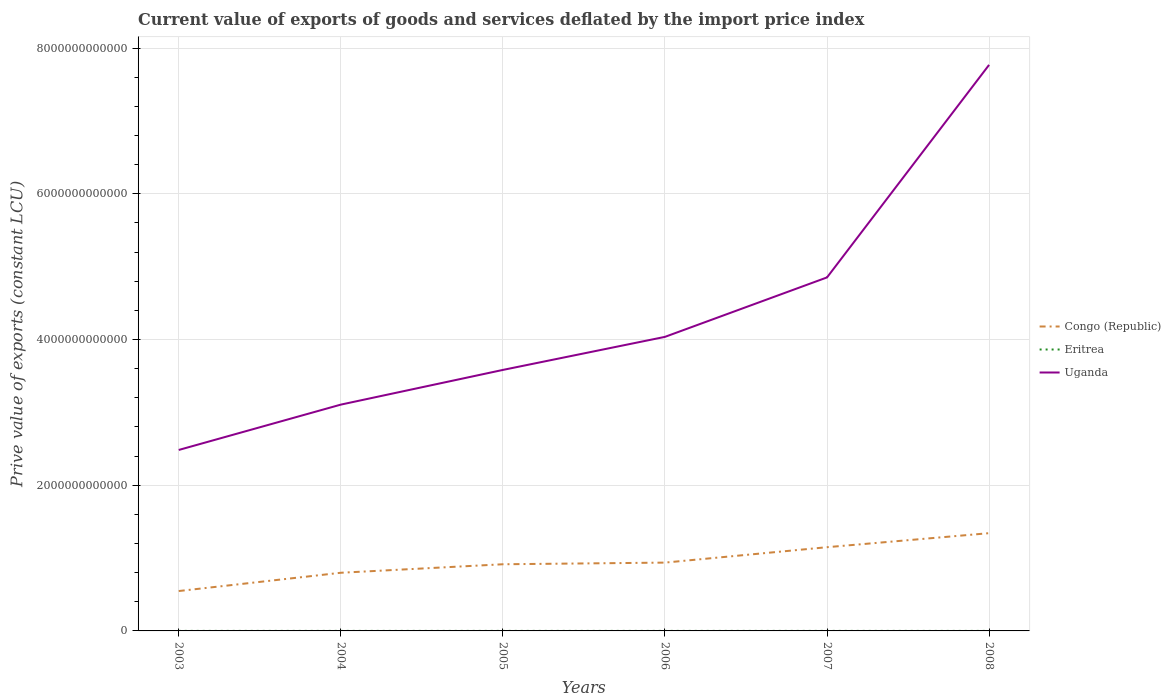How many different coloured lines are there?
Keep it short and to the point. 3. Across all years, what is the maximum prive value of exports in Uganda?
Give a very brief answer. 2.48e+12. In which year was the prive value of exports in Eritrea maximum?
Make the answer very short. 2008. What is the total prive value of exports in Uganda in the graph?
Keep it short and to the point. -2.92e+12. What is the difference between the highest and the second highest prive value of exports in Uganda?
Provide a short and direct response. 5.28e+12. Is the prive value of exports in Congo (Republic) strictly greater than the prive value of exports in Uganda over the years?
Your answer should be compact. Yes. How many years are there in the graph?
Offer a terse response. 6. What is the difference between two consecutive major ticks on the Y-axis?
Ensure brevity in your answer.  2.00e+12. Does the graph contain any zero values?
Your response must be concise. No. How many legend labels are there?
Your response must be concise. 3. How are the legend labels stacked?
Your answer should be very brief. Vertical. What is the title of the graph?
Give a very brief answer. Current value of exports of goods and services deflated by the import price index. Does "San Marino" appear as one of the legend labels in the graph?
Offer a terse response. No. What is the label or title of the X-axis?
Offer a very short reply. Years. What is the label or title of the Y-axis?
Provide a short and direct response. Prive value of exports (constant LCU). What is the Prive value of exports (constant LCU) in Congo (Republic) in 2003?
Give a very brief answer. 5.47e+11. What is the Prive value of exports (constant LCU) of Eritrea in 2003?
Provide a succinct answer. 5.18e+08. What is the Prive value of exports (constant LCU) of Uganda in 2003?
Your response must be concise. 2.48e+12. What is the Prive value of exports (constant LCU) in Congo (Republic) in 2004?
Keep it short and to the point. 7.98e+11. What is the Prive value of exports (constant LCU) of Eritrea in 2004?
Your answer should be very brief. 5.17e+08. What is the Prive value of exports (constant LCU) of Uganda in 2004?
Your answer should be compact. 3.11e+12. What is the Prive value of exports (constant LCU) of Congo (Republic) in 2005?
Offer a very short reply. 9.15e+11. What is the Prive value of exports (constant LCU) of Eritrea in 2005?
Keep it short and to the point. 4.69e+08. What is the Prive value of exports (constant LCU) of Uganda in 2005?
Your response must be concise. 3.58e+12. What is the Prive value of exports (constant LCU) in Congo (Republic) in 2006?
Make the answer very short. 9.38e+11. What is the Prive value of exports (constant LCU) in Eritrea in 2006?
Make the answer very short. 4.60e+08. What is the Prive value of exports (constant LCU) of Uganda in 2006?
Your answer should be very brief. 4.04e+12. What is the Prive value of exports (constant LCU) of Congo (Republic) in 2007?
Offer a terse response. 1.15e+12. What is the Prive value of exports (constant LCU) in Eritrea in 2007?
Ensure brevity in your answer.  3.60e+08. What is the Prive value of exports (constant LCU) in Uganda in 2007?
Ensure brevity in your answer.  4.85e+12. What is the Prive value of exports (constant LCU) of Congo (Republic) in 2008?
Your response must be concise. 1.34e+12. What is the Prive value of exports (constant LCU) of Eritrea in 2008?
Keep it short and to the point. 2.74e+08. What is the Prive value of exports (constant LCU) of Uganda in 2008?
Provide a short and direct response. 7.77e+12. Across all years, what is the maximum Prive value of exports (constant LCU) in Congo (Republic)?
Offer a very short reply. 1.34e+12. Across all years, what is the maximum Prive value of exports (constant LCU) of Eritrea?
Your response must be concise. 5.18e+08. Across all years, what is the maximum Prive value of exports (constant LCU) in Uganda?
Provide a short and direct response. 7.77e+12. Across all years, what is the minimum Prive value of exports (constant LCU) of Congo (Republic)?
Ensure brevity in your answer.  5.47e+11. Across all years, what is the minimum Prive value of exports (constant LCU) in Eritrea?
Your answer should be very brief. 2.74e+08. Across all years, what is the minimum Prive value of exports (constant LCU) in Uganda?
Keep it short and to the point. 2.48e+12. What is the total Prive value of exports (constant LCU) of Congo (Republic) in the graph?
Keep it short and to the point. 5.69e+12. What is the total Prive value of exports (constant LCU) in Eritrea in the graph?
Your answer should be compact. 2.60e+09. What is the total Prive value of exports (constant LCU) in Uganda in the graph?
Keep it short and to the point. 2.58e+13. What is the difference between the Prive value of exports (constant LCU) of Congo (Republic) in 2003 and that in 2004?
Your answer should be very brief. -2.51e+11. What is the difference between the Prive value of exports (constant LCU) in Eritrea in 2003 and that in 2004?
Offer a very short reply. 6.15e+05. What is the difference between the Prive value of exports (constant LCU) in Uganda in 2003 and that in 2004?
Ensure brevity in your answer.  -6.22e+11. What is the difference between the Prive value of exports (constant LCU) of Congo (Republic) in 2003 and that in 2005?
Provide a short and direct response. -3.68e+11. What is the difference between the Prive value of exports (constant LCU) of Eritrea in 2003 and that in 2005?
Your response must be concise. 4.90e+07. What is the difference between the Prive value of exports (constant LCU) in Uganda in 2003 and that in 2005?
Your answer should be compact. -1.10e+12. What is the difference between the Prive value of exports (constant LCU) of Congo (Republic) in 2003 and that in 2006?
Give a very brief answer. -3.90e+11. What is the difference between the Prive value of exports (constant LCU) in Eritrea in 2003 and that in 2006?
Offer a terse response. 5.82e+07. What is the difference between the Prive value of exports (constant LCU) in Uganda in 2003 and that in 2006?
Your response must be concise. -1.55e+12. What is the difference between the Prive value of exports (constant LCU) of Congo (Republic) in 2003 and that in 2007?
Keep it short and to the point. -6.02e+11. What is the difference between the Prive value of exports (constant LCU) in Eritrea in 2003 and that in 2007?
Your answer should be very brief. 1.58e+08. What is the difference between the Prive value of exports (constant LCU) of Uganda in 2003 and that in 2007?
Make the answer very short. -2.37e+12. What is the difference between the Prive value of exports (constant LCU) in Congo (Republic) in 2003 and that in 2008?
Your response must be concise. -7.94e+11. What is the difference between the Prive value of exports (constant LCU) of Eritrea in 2003 and that in 2008?
Provide a short and direct response. 2.44e+08. What is the difference between the Prive value of exports (constant LCU) in Uganda in 2003 and that in 2008?
Your answer should be compact. -5.28e+12. What is the difference between the Prive value of exports (constant LCU) of Congo (Republic) in 2004 and that in 2005?
Provide a succinct answer. -1.17e+11. What is the difference between the Prive value of exports (constant LCU) of Eritrea in 2004 and that in 2005?
Keep it short and to the point. 4.84e+07. What is the difference between the Prive value of exports (constant LCU) in Uganda in 2004 and that in 2005?
Offer a very short reply. -4.76e+11. What is the difference between the Prive value of exports (constant LCU) of Congo (Republic) in 2004 and that in 2006?
Keep it short and to the point. -1.39e+11. What is the difference between the Prive value of exports (constant LCU) in Eritrea in 2004 and that in 2006?
Provide a succinct answer. 5.76e+07. What is the difference between the Prive value of exports (constant LCU) of Uganda in 2004 and that in 2006?
Provide a short and direct response. -9.30e+11. What is the difference between the Prive value of exports (constant LCU) of Congo (Republic) in 2004 and that in 2007?
Make the answer very short. -3.51e+11. What is the difference between the Prive value of exports (constant LCU) in Eritrea in 2004 and that in 2007?
Your response must be concise. 1.58e+08. What is the difference between the Prive value of exports (constant LCU) in Uganda in 2004 and that in 2007?
Your answer should be compact. -1.75e+12. What is the difference between the Prive value of exports (constant LCU) in Congo (Republic) in 2004 and that in 2008?
Provide a short and direct response. -5.43e+11. What is the difference between the Prive value of exports (constant LCU) of Eritrea in 2004 and that in 2008?
Your response must be concise. 2.44e+08. What is the difference between the Prive value of exports (constant LCU) in Uganda in 2004 and that in 2008?
Ensure brevity in your answer.  -4.66e+12. What is the difference between the Prive value of exports (constant LCU) in Congo (Republic) in 2005 and that in 2006?
Ensure brevity in your answer.  -2.27e+1. What is the difference between the Prive value of exports (constant LCU) of Eritrea in 2005 and that in 2006?
Provide a succinct answer. 9.15e+06. What is the difference between the Prive value of exports (constant LCU) in Uganda in 2005 and that in 2006?
Make the answer very short. -4.54e+11. What is the difference between the Prive value of exports (constant LCU) of Congo (Republic) in 2005 and that in 2007?
Provide a succinct answer. -2.34e+11. What is the difference between the Prive value of exports (constant LCU) of Eritrea in 2005 and that in 2007?
Your answer should be very brief. 1.09e+08. What is the difference between the Prive value of exports (constant LCU) in Uganda in 2005 and that in 2007?
Make the answer very short. -1.27e+12. What is the difference between the Prive value of exports (constant LCU) of Congo (Republic) in 2005 and that in 2008?
Your answer should be very brief. -4.27e+11. What is the difference between the Prive value of exports (constant LCU) in Eritrea in 2005 and that in 2008?
Keep it short and to the point. 1.95e+08. What is the difference between the Prive value of exports (constant LCU) in Uganda in 2005 and that in 2008?
Provide a short and direct response. -4.19e+12. What is the difference between the Prive value of exports (constant LCU) of Congo (Republic) in 2006 and that in 2007?
Give a very brief answer. -2.12e+11. What is the difference between the Prive value of exports (constant LCU) in Eritrea in 2006 and that in 2007?
Offer a very short reply. 1.00e+08. What is the difference between the Prive value of exports (constant LCU) in Uganda in 2006 and that in 2007?
Provide a succinct answer. -8.16e+11. What is the difference between the Prive value of exports (constant LCU) of Congo (Republic) in 2006 and that in 2008?
Your answer should be very brief. -4.04e+11. What is the difference between the Prive value of exports (constant LCU) of Eritrea in 2006 and that in 2008?
Ensure brevity in your answer.  1.86e+08. What is the difference between the Prive value of exports (constant LCU) of Uganda in 2006 and that in 2008?
Your response must be concise. -3.73e+12. What is the difference between the Prive value of exports (constant LCU) in Congo (Republic) in 2007 and that in 2008?
Provide a short and direct response. -1.93e+11. What is the difference between the Prive value of exports (constant LCU) in Eritrea in 2007 and that in 2008?
Give a very brief answer. 8.60e+07. What is the difference between the Prive value of exports (constant LCU) in Uganda in 2007 and that in 2008?
Your answer should be compact. -2.92e+12. What is the difference between the Prive value of exports (constant LCU) of Congo (Republic) in 2003 and the Prive value of exports (constant LCU) of Eritrea in 2004?
Your answer should be compact. 5.47e+11. What is the difference between the Prive value of exports (constant LCU) in Congo (Republic) in 2003 and the Prive value of exports (constant LCU) in Uganda in 2004?
Offer a terse response. -2.56e+12. What is the difference between the Prive value of exports (constant LCU) in Eritrea in 2003 and the Prive value of exports (constant LCU) in Uganda in 2004?
Provide a short and direct response. -3.11e+12. What is the difference between the Prive value of exports (constant LCU) of Congo (Republic) in 2003 and the Prive value of exports (constant LCU) of Eritrea in 2005?
Your answer should be very brief. 5.47e+11. What is the difference between the Prive value of exports (constant LCU) of Congo (Republic) in 2003 and the Prive value of exports (constant LCU) of Uganda in 2005?
Keep it short and to the point. -3.03e+12. What is the difference between the Prive value of exports (constant LCU) of Eritrea in 2003 and the Prive value of exports (constant LCU) of Uganda in 2005?
Your response must be concise. -3.58e+12. What is the difference between the Prive value of exports (constant LCU) of Congo (Republic) in 2003 and the Prive value of exports (constant LCU) of Eritrea in 2006?
Provide a succinct answer. 5.47e+11. What is the difference between the Prive value of exports (constant LCU) in Congo (Republic) in 2003 and the Prive value of exports (constant LCU) in Uganda in 2006?
Make the answer very short. -3.49e+12. What is the difference between the Prive value of exports (constant LCU) of Eritrea in 2003 and the Prive value of exports (constant LCU) of Uganda in 2006?
Offer a very short reply. -4.04e+12. What is the difference between the Prive value of exports (constant LCU) in Congo (Republic) in 2003 and the Prive value of exports (constant LCU) in Eritrea in 2007?
Your answer should be compact. 5.47e+11. What is the difference between the Prive value of exports (constant LCU) in Congo (Republic) in 2003 and the Prive value of exports (constant LCU) in Uganda in 2007?
Offer a very short reply. -4.30e+12. What is the difference between the Prive value of exports (constant LCU) of Eritrea in 2003 and the Prive value of exports (constant LCU) of Uganda in 2007?
Keep it short and to the point. -4.85e+12. What is the difference between the Prive value of exports (constant LCU) of Congo (Republic) in 2003 and the Prive value of exports (constant LCU) of Eritrea in 2008?
Make the answer very short. 5.47e+11. What is the difference between the Prive value of exports (constant LCU) of Congo (Republic) in 2003 and the Prive value of exports (constant LCU) of Uganda in 2008?
Provide a short and direct response. -7.22e+12. What is the difference between the Prive value of exports (constant LCU) in Eritrea in 2003 and the Prive value of exports (constant LCU) in Uganda in 2008?
Ensure brevity in your answer.  -7.77e+12. What is the difference between the Prive value of exports (constant LCU) of Congo (Republic) in 2004 and the Prive value of exports (constant LCU) of Eritrea in 2005?
Offer a very short reply. 7.98e+11. What is the difference between the Prive value of exports (constant LCU) of Congo (Republic) in 2004 and the Prive value of exports (constant LCU) of Uganda in 2005?
Keep it short and to the point. -2.78e+12. What is the difference between the Prive value of exports (constant LCU) of Eritrea in 2004 and the Prive value of exports (constant LCU) of Uganda in 2005?
Provide a succinct answer. -3.58e+12. What is the difference between the Prive value of exports (constant LCU) in Congo (Republic) in 2004 and the Prive value of exports (constant LCU) in Eritrea in 2006?
Your response must be concise. 7.98e+11. What is the difference between the Prive value of exports (constant LCU) of Congo (Republic) in 2004 and the Prive value of exports (constant LCU) of Uganda in 2006?
Ensure brevity in your answer.  -3.24e+12. What is the difference between the Prive value of exports (constant LCU) in Eritrea in 2004 and the Prive value of exports (constant LCU) in Uganda in 2006?
Keep it short and to the point. -4.04e+12. What is the difference between the Prive value of exports (constant LCU) in Congo (Republic) in 2004 and the Prive value of exports (constant LCU) in Eritrea in 2007?
Your answer should be very brief. 7.98e+11. What is the difference between the Prive value of exports (constant LCU) of Congo (Republic) in 2004 and the Prive value of exports (constant LCU) of Uganda in 2007?
Make the answer very short. -4.05e+12. What is the difference between the Prive value of exports (constant LCU) of Eritrea in 2004 and the Prive value of exports (constant LCU) of Uganda in 2007?
Give a very brief answer. -4.85e+12. What is the difference between the Prive value of exports (constant LCU) of Congo (Republic) in 2004 and the Prive value of exports (constant LCU) of Eritrea in 2008?
Offer a very short reply. 7.98e+11. What is the difference between the Prive value of exports (constant LCU) of Congo (Republic) in 2004 and the Prive value of exports (constant LCU) of Uganda in 2008?
Your response must be concise. -6.97e+12. What is the difference between the Prive value of exports (constant LCU) in Eritrea in 2004 and the Prive value of exports (constant LCU) in Uganda in 2008?
Make the answer very short. -7.77e+12. What is the difference between the Prive value of exports (constant LCU) of Congo (Republic) in 2005 and the Prive value of exports (constant LCU) of Eritrea in 2006?
Give a very brief answer. 9.14e+11. What is the difference between the Prive value of exports (constant LCU) of Congo (Republic) in 2005 and the Prive value of exports (constant LCU) of Uganda in 2006?
Keep it short and to the point. -3.12e+12. What is the difference between the Prive value of exports (constant LCU) in Eritrea in 2005 and the Prive value of exports (constant LCU) in Uganda in 2006?
Your answer should be compact. -4.04e+12. What is the difference between the Prive value of exports (constant LCU) of Congo (Republic) in 2005 and the Prive value of exports (constant LCU) of Eritrea in 2007?
Provide a succinct answer. 9.15e+11. What is the difference between the Prive value of exports (constant LCU) in Congo (Republic) in 2005 and the Prive value of exports (constant LCU) in Uganda in 2007?
Make the answer very short. -3.94e+12. What is the difference between the Prive value of exports (constant LCU) in Eritrea in 2005 and the Prive value of exports (constant LCU) in Uganda in 2007?
Your answer should be very brief. -4.85e+12. What is the difference between the Prive value of exports (constant LCU) of Congo (Republic) in 2005 and the Prive value of exports (constant LCU) of Eritrea in 2008?
Your answer should be compact. 9.15e+11. What is the difference between the Prive value of exports (constant LCU) in Congo (Republic) in 2005 and the Prive value of exports (constant LCU) in Uganda in 2008?
Provide a succinct answer. -6.85e+12. What is the difference between the Prive value of exports (constant LCU) in Eritrea in 2005 and the Prive value of exports (constant LCU) in Uganda in 2008?
Your answer should be very brief. -7.77e+12. What is the difference between the Prive value of exports (constant LCU) of Congo (Republic) in 2006 and the Prive value of exports (constant LCU) of Eritrea in 2007?
Provide a short and direct response. 9.37e+11. What is the difference between the Prive value of exports (constant LCU) in Congo (Republic) in 2006 and the Prive value of exports (constant LCU) in Uganda in 2007?
Give a very brief answer. -3.91e+12. What is the difference between the Prive value of exports (constant LCU) in Eritrea in 2006 and the Prive value of exports (constant LCU) in Uganda in 2007?
Provide a short and direct response. -4.85e+12. What is the difference between the Prive value of exports (constant LCU) in Congo (Republic) in 2006 and the Prive value of exports (constant LCU) in Eritrea in 2008?
Offer a very short reply. 9.37e+11. What is the difference between the Prive value of exports (constant LCU) of Congo (Republic) in 2006 and the Prive value of exports (constant LCU) of Uganda in 2008?
Ensure brevity in your answer.  -6.83e+12. What is the difference between the Prive value of exports (constant LCU) of Eritrea in 2006 and the Prive value of exports (constant LCU) of Uganda in 2008?
Offer a terse response. -7.77e+12. What is the difference between the Prive value of exports (constant LCU) of Congo (Republic) in 2007 and the Prive value of exports (constant LCU) of Eritrea in 2008?
Your answer should be compact. 1.15e+12. What is the difference between the Prive value of exports (constant LCU) of Congo (Republic) in 2007 and the Prive value of exports (constant LCU) of Uganda in 2008?
Offer a terse response. -6.62e+12. What is the difference between the Prive value of exports (constant LCU) of Eritrea in 2007 and the Prive value of exports (constant LCU) of Uganda in 2008?
Offer a terse response. -7.77e+12. What is the average Prive value of exports (constant LCU) in Congo (Republic) per year?
Give a very brief answer. 9.48e+11. What is the average Prive value of exports (constant LCU) in Eritrea per year?
Provide a succinct answer. 4.33e+08. What is the average Prive value of exports (constant LCU) of Uganda per year?
Give a very brief answer. 4.30e+12. In the year 2003, what is the difference between the Prive value of exports (constant LCU) of Congo (Republic) and Prive value of exports (constant LCU) of Eritrea?
Your response must be concise. 5.47e+11. In the year 2003, what is the difference between the Prive value of exports (constant LCU) in Congo (Republic) and Prive value of exports (constant LCU) in Uganda?
Provide a short and direct response. -1.94e+12. In the year 2003, what is the difference between the Prive value of exports (constant LCU) of Eritrea and Prive value of exports (constant LCU) of Uganda?
Offer a very short reply. -2.48e+12. In the year 2004, what is the difference between the Prive value of exports (constant LCU) in Congo (Republic) and Prive value of exports (constant LCU) in Eritrea?
Your answer should be very brief. 7.98e+11. In the year 2004, what is the difference between the Prive value of exports (constant LCU) of Congo (Republic) and Prive value of exports (constant LCU) of Uganda?
Give a very brief answer. -2.31e+12. In the year 2004, what is the difference between the Prive value of exports (constant LCU) of Eritrea and Prive value of exports (constant LCU) of Uganda?
Your answer should be compact. -3.11e+12. In the year 2005, what is the difference between the Prive value of exports (constant LCU) of Congo (Republic) and Prive value of exports (constant LCU) of Eritrea?
Give a very brief answer. 9.14e+11. In the year 2005, what is the difference between the Prive value of exports (constant LCU) of Congo (Republic) and Prive value of exports (constant LCU) of Uganda?
Provide a succinct answer. -2.67e+12. In the year 2005, what is the difference between the Prive value of exports (constant LCU) of Eritrea and Prive value of exports (constant LCU) of Uganda?
Keep it short and to the point. -3.58e+12. In the year 2006, what is the difference between the Prive value of exports (constant LCU) in Congo (Republic) and Prive value of exports (constant LCU) in Eritrea?
Your answer should be very brief. 9.37e+11. In the year 2006, what is the difference between the Prive value of exports (constant LCU) of Congo (Republic) and Prive value of exports (constant LCU) of Uganda?
Make the answer very short. -3.10e+12. In the year 2006, what is the difference between the Prive value of exports (constant LCU) of Eritrea and Prive value of exports (constant LCU) of Uganda?
Give a very brief answer. -4.04e+12. In the year 2007, what is the difference between the Prive value of exports (constant LCU) of Congo (Republic) and Prive value of exports (constant LCU) of Eritrea?
Your answer should be compact. 1.15e+12. In the year 2007, what is the difference between the Prive value of exports (constant LCU) of Congo (Republic) and Prive value of exports (constant LCU) of Uganda?
Your response must be concise. -3.70e+12. In the year 2007, what is the difference between the Prive value of exports (constant LCU) of Eritrea and Prive value of exports (constant LCU) of Uganda?
Give a very brief answer. -4.85e+12. In the year 2008, what is the difference between the Prive value of exports (constant LCU) in Congo (Republic) and Prive value of exports (constant LCU) in Eritrea?
Give a very brief answer. 1.34e+12. In the year 2008, what is the difference between the Prive value of exports (constant LCU) of Congo (Republic) and Prive value of exports (constant LCU) of Uganda?
Make the answer very short. -6.43e+12. In the year 2008, what is the difference between the Prive value of exports (constant LCU) of Eritrea and Prive value of exports (constant LCU) of Uganda?
Offer a terse response. -7.77e+12. What is the ratio of the Prive value of exports (constant LCU) of Congo (Republic) in 2003 to that in 2004?
Ensure brevity in your answer.  0.69. What is the ratio of the Prive value of exports (constant LCU) of Uganda in 2003 to that in 2004?
Make the answer very short. 0.8. What is the ratio of the Prive value of exports (constant LCU) in Congo (Republic) in 2003 to that in 2005?
Your answer should be compact. 0.6. What is the ratio of the Prive value of exports (constant LCU) of Eritrea in 2003 to that in 2005?
Offer a terse response. 1.1. What is the ratio of the Prive value of exports (constant LCU) of Uganda in 2003 to that in 2005?
Your answer should be very brief. 0.69. What is the ratio of the Prive value of exports (constant LCU) in Congo (Republic) in 2003 to that in 2006?
Ensure brevity in your answer.  0.58. What is the ratio of the Prive value of exports (constant LCU) in Eritrea in 2003 to that in 2006?
Your answer should be compact. 1.13. What is the ratio of the Prive value of exports (constant LCU) in Uganda in 2003 to that in 2006?
Give a very brief answer. 0.62. What is the ratio of the Prive value of exports (constant LCU) of Congo (Republic) in 2003 to that in 2007?
Provide a succinct answer. 0.48. What is the ratio of the Prive value of exports (constant LCU) in Eritrea in 2003 to that in 2007?
Ensure brevity in your answer.  1.44. What is the ratio of the Prive value of exports (constant LCU) in Uganda in 2003 to that in 2007?
Provide a short and direct response. 0.51. What is the ratio of the Prive value of exports (constant LCU) in Congo (Republic) in 2003 to that in 2008?
Offer a very short reply. 0.41. What is the ratio of the Prive value of exports (constant LCU) of Eritrea in 2003 to that in 2008?
Provide a succinct answer. 1.89. What is the ratio of the Prive value of exports (constant LCU) of Uganda in 2003 to that in 2008?
Your response must be concise. 0.32. What is the ratio of the Prive value of exports (constant LCU) in Congo (Republic) in 2004 to that in 2005?
Offer a terse response. 0.87. What is the ratio of the Prive value of exports (constant LCU) of Eritrea in 2004 to that in 2005?
Provide a succinct answer. 1.1. What is the ratio of the Prive value of exports (constant LCU) in Uganda in 2004 to that in 2005?
Ensure brevity in your answer.  0.87. What is the ratio of the Prive value of exports (constant LCU) in Congo (Republic) in 2004 to that in 2006?
Your response must be concise. 0.85. What is the ratio of the Prive value of exports (constant LCU) of Eritrea in 2004 to that in 2006?
Your answer should be very brief. 1.13. What is the ratio of the Prive value of exports (constant LCU) in Uganda in 2004 to that in 2006?
Offer a terse response. 0.77. What is the ratio of the Prive value of exports (constant LCU) of Congo (Republic) in 2004 to that in 2007?
Provide a short and direct response. 0.69. What is the ratio of the Prive value of exports (constant LCU) of Eritrea in 2004 to that in 2007?
Offer a terse response. 1.44. What is the ratio of the Prive value of exports (constant LCU) of Uganda in 2004 to that in 2007?
Give a very brief answer. 0.64. What is the ratio of the Prive value of exports (constant LCU) of Congo (Republic) in 2004 to that in 2008?
Provide a succinct answer. 0.59. What is the ratio of the Prive value of exports (constant LCU) of Eritrea in 2004 to that in 2008?
Make the answer very short. 1.89. What is the ratio of the Prive value of exports (constant LCU) of Uganda in 2004 to that in 2008?
Your answer should be compact. 0.4. What is the ratio of the Prive value of exports (constant LCU) in Congo (Republic) in 2005 to that in 2006?
Give a very brief answer. 0.98. What is the ratio of the Prive value of exports (constant LCU) in Eritrea in 2005 to that in 2006?
Offer a terse response. 1.02. What is the ratio of the Prive value of exports (constant LCU) in Uganda in 2005 to that in 2006?
Your answer should be compact. 0.89. What is the ratio of the Prive value of exports (constant LCU) of Congo (Republic) in 2005 to that in 2007?
Your response must be concise. 0.8. What is the ratio of the Prive value of exports (constant LCU) in Eritrea in 2005 to that in 2007?
Provide a short and direct response. 1.3. What is the ratio of the Prive value of exports (constant LCU) of Uganda in 2005 to that in 2007?
Offer a very short reply. 0.74. What is the ratio of the Prive value of exports (constant LCU) of Congo (Republic) in 2005 to that in 2008?
Provide a succinct answer. 0.68. What is the ratio of the Prive value of exports (constant LCU) of Eritrea in 2005 to that in 2008?
Make the answer very short. 1.71. What is the ratio of the Prive value of exports (constant LCU) of Uganda in 2005 to that in 2008?
Provide a succinct answer. 0.46. What is the ratio of the Prive value of exports (constant LCU) in Congo (Republic) in 2006 to that in 2007?
Provide a succinct answer. 0.82. What is the ratio of the Prive value of exports (constant LCU) of Eritrea in 2006 to that in 2007?
Keep it short and to the point. 1.28. What is the ratio of the Prive value of exports (constant LCU) in Uganda in 2006 to that in 2007?
Provide a short and direct response. 0.83. What is the ratio of the Prive value of exports (constant LCU) of Congo (Republic) in 2006 to that in 2008?
Your answer should be very brief. 0.7. What is the ratio of the Prive value of exports (constant LCU) of Eritrea in 2006 to that in 2008?
Make the answer very short. 1.68. What is the ratio of the Prive value of exports (constant LCU) in Uganda in 2006 to that in 2008?
Offer a terse response. 0.52. What is the ratio of the Prive value of exports (constant LCU) of Congo (Republic) in 2007 to that in 2008?
Provide a short and direct response. 0.86. What is the ratio of the Prive value of exports (constant LCU) of Eritrea in 2007 to that in 2008?
Offer a terse response. 1.31. What is the ratio of the Prive value of exports (constant LCU) in Uganda in 2007 to that in 2008?
Provide a succinct answer. 0.62. What is the difference between the highest and the second highest Prive value of exports (constant LCU) in Congo (Republic)?
Keep it short and to the point. 1.93e+11. What is the difference between the highest and the second highest Prive value of exports (constant LCU) of Eritrea?
Your answer should be very brief. 6.15e+05. What is the difference between the highest and the second highest Prive value of exports (constant LCU) of Uganda?
Provide a succinct answer. 2.92e+12. What is the difference between the highest and the lowest Prive value of exports (constant LCU) in Congo (Republic)?
Keep it short and to the point. 7.94e+11. What is the difference between the highest and the lowest Prive value of exports (constant LCU) in Eritrea?
Provide a succinct answer. 2.44e+08. What is the difference between the highest and the lowest Prive value of exports (constant LCU) in Uganda?
Provide a succinct answer. 5.28e+12. 